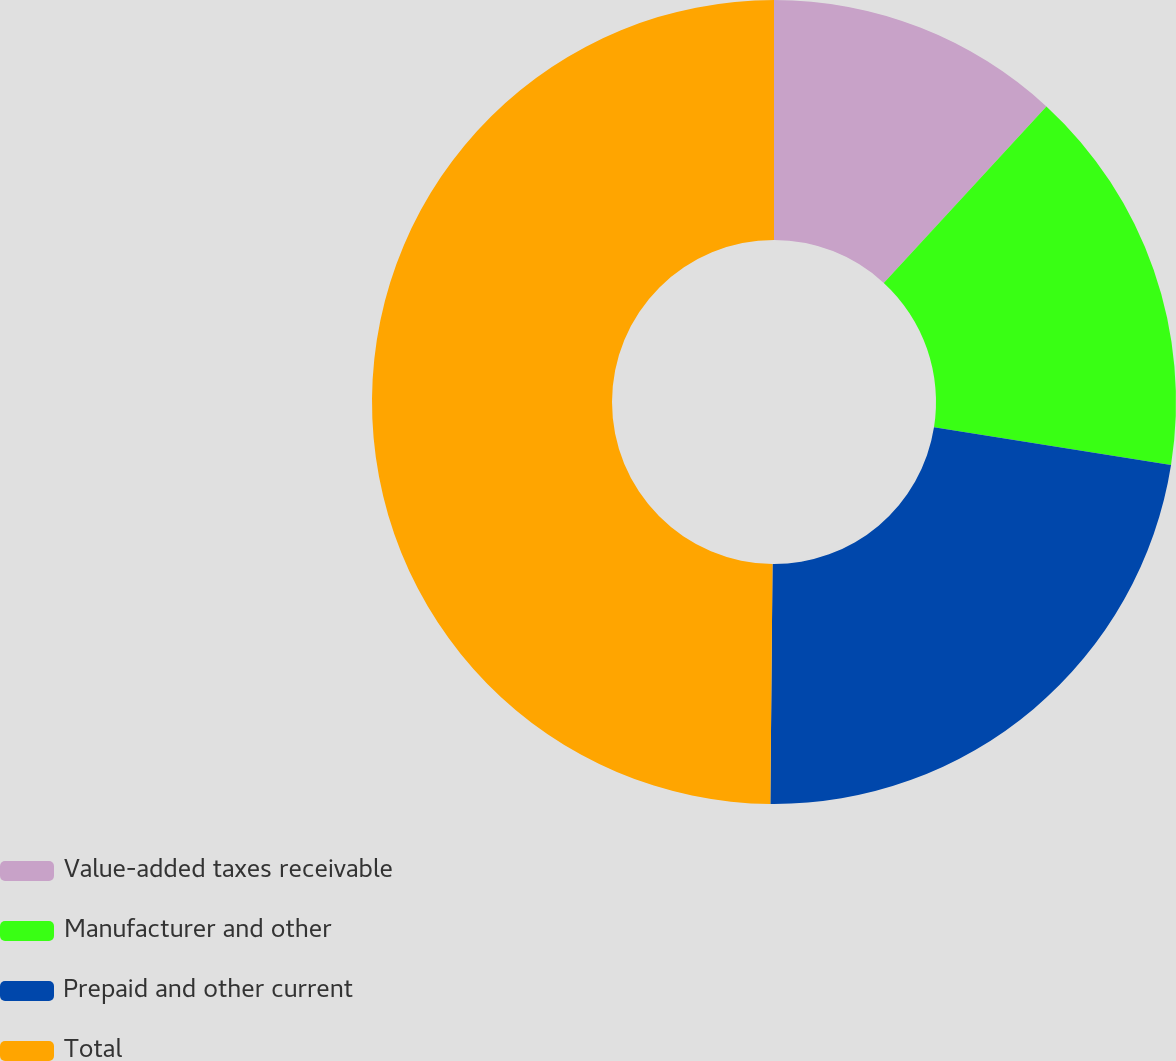Convert chart. <chart><loc_0><loc_0><loc_500><loc_500><pie_chart><fcel>Value-added taxes receivable<fcel>Manufacturer and other<fcel>Prepaid and other current<fcel>Total<nl><fcel>11.85%<fcel>15.65%<fcel>22.64%<fcel>49.85%<nl></chart> 